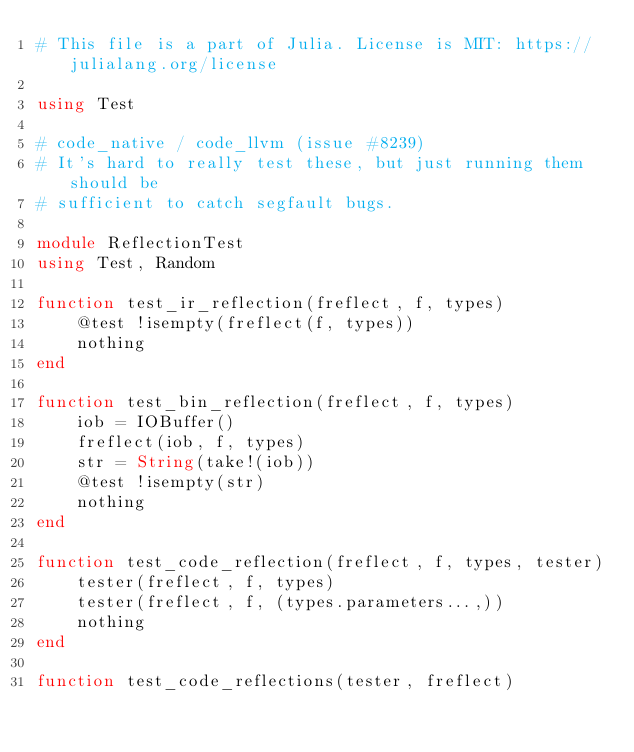<code> <loc_0><loc_0><loc_500><loc_500><_Julia_># This file is a part of Julia. License is MIT: https://julialang.org/license

using Test

# code_native / code_llvm (issue #8239)
# It's hard to really test these, but just running them should be
# sufficient to catch segfault bugs.

module ReflectionTest
using Test, Random

function test_ir_reflection(freflect, f, types)
    @test !isempty(freflect(f, types))
    nothing
end

function test_bin_reflection(freflect, f, types)
    iob = IOBuffer()
    freflect(iob, f, types)
    str = String(take!(iob))
    @test !isempty(str)
    nothing
end

function test_code_reflection(freflect, f, types, tester)
    tester(freflect, f, types)
    tester(freflect, f, (types.parameters...,))
    nothing
end

function test_code_reflections(tester, freflect)</code> 